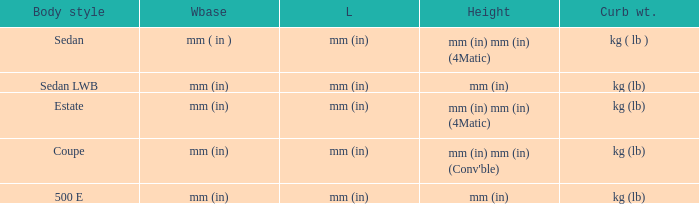What are the lengths of the models that are mm (in) tall? Mm (in), mm (in). 